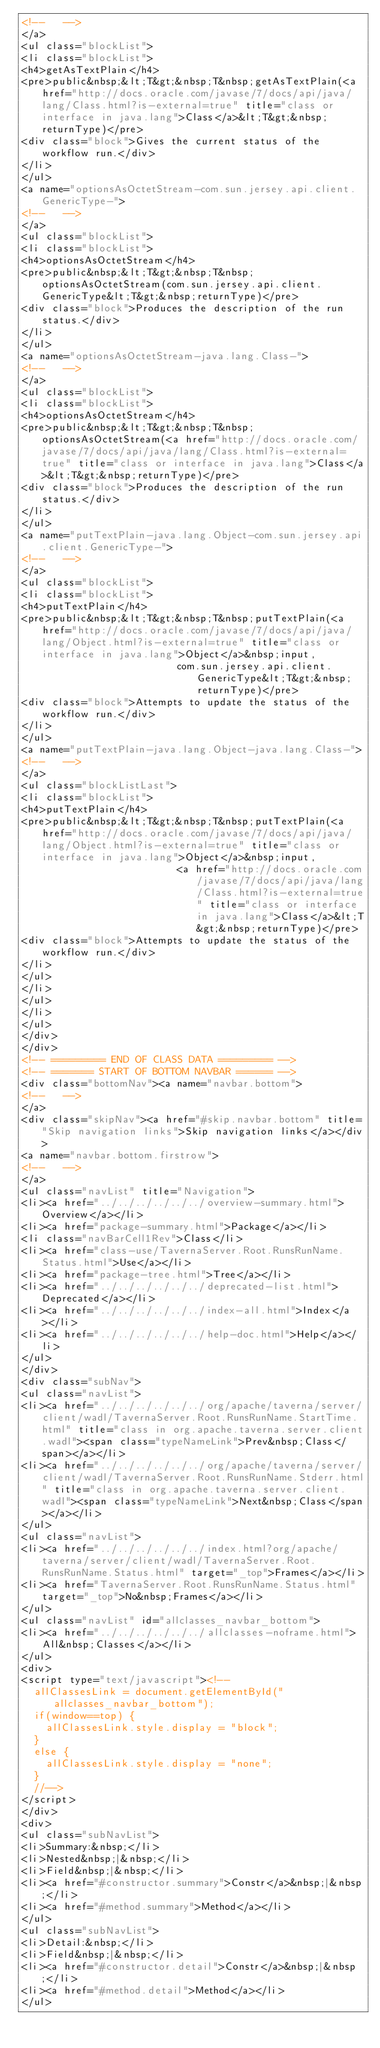<code> <loc_0><loc_0><loc_500><loc_500><_HTML_><!--   -->
</a>
<ul class="blockList">
<li class="blockList">
<h4>getAsTextPlain</h4>
<pre>public&nbsp;&lt;T&gt;&nbsp;T&nbsp;getAsTextPlain(<a href="http://docs.oracle.com/javase/7/docs/api/java/lang/Class.html?is-external=true" title="class or interface in java.lang">Class</a>&lt;T&gt;&nbsp;returnType)</pre>
<div class="block">Gives the current status of the workflow run.</div>
</li>
</ul>
<a name="optionsAsOctetStream-com.sun.jersey.api.client.GenericType-">
<!--   -->
</a>
<ul class="blockList">
<li class="blockList">
<h4>optionsAsOctetStream</h4>
<pre>public&nbsp;&lt;T&gt;&nbsp;T&nbsp;optionsAsOctetStream(com.sun.jersey.api.client.GenericType&lt;T&gt;&nbsp;returnType)</pre>
<div class="block">Produces the description of the run status.</div>
</li>
</ul>
<a name="optionsAsOctetStream-java.lang.Class-">
<!--   -->
</a>
<ul class="blockList">
<li class="blockList">
<h4>optionsAsOctetStream</h4>
<pre>public&nbsp;&lt;T&gt;&nbsp;T&nbsp;optionsAsOctetStream(<a href="http://docs.oracle.com/javase/7/docs/api/java/lang/Class.html?is-external=true" title="class or interface in java.lang">Class</a>&lt;T&gt;&nbsp;returnType)</pre>
<div class="block">Produces the description of the run status.</div>
</li>
</ul>
<a name="putTextPlain-java.lang.Object-com.sun.jersey.api.client.GenericType-">
<!--   -->
</a>
<ul class="blockList">
<li class="blockList">
<h4>putTextPlain</h4>
<pre>public&nbsp;&lt;T&gt;&nbsp;T&nbsp;putTextPlain(<a href="http://docs.oracle.com/javase/7/docs/api/java/lang/Object.html?is-external=true" title="class or interface in java.lang">Object</a>&nbsp;input,
                          com.sun.jersey.api.client.GenericType&lt;T&gt;&nbsp;returnType)</pre>
<div class="block">Attempts to update the status of the workflow run.</div>
</li>
</ul>
<a name="putTextPlain-java.lang.Object-java.lang.Class-">
<!--   -->
</a>
<ul class="blockListLast">
<li class="blockList">
<h4>putTextPlain</h4>
<pre>public&nbsp;&lt;T&gt;&nbsp;T&nbsp;putTextPlain(<a href="http://docs.oracle.com/javase/7/docs/api/java/lang/Object.html?is-external=true" title="class or interface in java.lang">Object</a>&nbsp;input,
                          <a href="http://docs.oracle.com/javase/7/docs/api/java/lang/Class.html?is-external=true" title="class or interface in java.lang">Class</a>&lt;T&gt;&nbsp;returnType)</pre>
<div class="block">Attempts to update the status of the workflow run.</div>
</li>
</ul>
</li>
</ul>
</li>
</ul>
</div>
</div>
<!-- ========= END OF CLASS DATA ========= -->
<!-- ======= START OF BOTTOM NAVBAR ====== -->
<div class="bottomNav"><a name="navbar.bottom">
<!--   -->
</a>
<div class="skipNav"><a href="#skip.navbar.bottom" title="Skip navigation links">Skip navigation links</a></div>
<a name="navbar.bottom.firstrow">
<!--   -->
</a>
<ul class="navList" title="Navigation">
<li><a href="../../../../../../overview-summary.html">Overview</a></li>
<li><a href="package-summary.html">Package</a></li>
<li class="navBarCell1Rev">Class</li>
<li><a href="class-use/TavernaServer.Root.RunsRunName.Status.html">Use</a></li>
<li><a href="package-tree.html">Tree</a></li>
<li><a href="../../../../../../deprecated-list.html">Deprecated</a></li>
<li><a href="../../../../../../index-all.html">Index</a></li>
<li><a href="../../../../../../help-doc.html">Help</a></li>
</ul>
</div>
<div class="subNav">
<ul class="navList">
<li><a href="../../../../../../org/apache/taverna/server/client/wadl/TavernaServer.Root.RunsRunName.StartTime.html" title="class in org.apache.taverna.server.client.wadl"><span class="typeNameLink">Prev&nbsp;Class</span></a></li>
<li><a href="../../../../../../org/apache/taverna/server/client/wadl/TavernaServer.Root.RunsRunName.Stderr.html" title="class in org.apache.taverna.server.client.wadl"><span class="typeNameLink">Next&nbsp;Class</span></a></li>
</ul>
<ul class="navList">
<li><a href="../../../../../../index.html?org/apache/taverna/server/client/wadl/TavernaServer.Root.RunsRunName.Status.html" target="_top">Frames</a></li>
<li><a href="TavernaServer.Root.RunsRunName.Status.html" target="_top">No&nbsp;Frames</a></li>
</ul>
<ul class="navList" id="allclasses_navbar_bottom">
<li><a href="../../../../../../allclasses-noframe.html">All&nbsp;Classes</a></li>
</ul>
<div>
<script type="text/javascript"><!--
  allClassesLink = document.getElementById("allclasses_navbar_bottom");
  if(window==top) {
    allClassesLink.style.display = "block";
  }
  else {
    allClassesLink.style.display = "none";
  }
  //-->
</script>
</div>
<div>
<ul class="subNavList">
<li>Summary:&nbsp;</li>
<li>Nested&nbsp;|&nbsp;</li>
<li>Field&nbsp;|&nbsp;</li>
<li><a href="#constructor.summary">Constr</a>&nbsp;|&nbsp;</li>
<li><a href="#method.summary">Method</a></li>
</ul>
<ul class="subNavList">
<li>Detail:&nbsp;</li>
<li>Field&nbsp;|&nbsp;</li>
<li><a href="#constructor.detail">Constr</a>&nbsp;|&nbsp;</li>
<li><a href="#method.detail">Method</a></li>
</ul></code> 